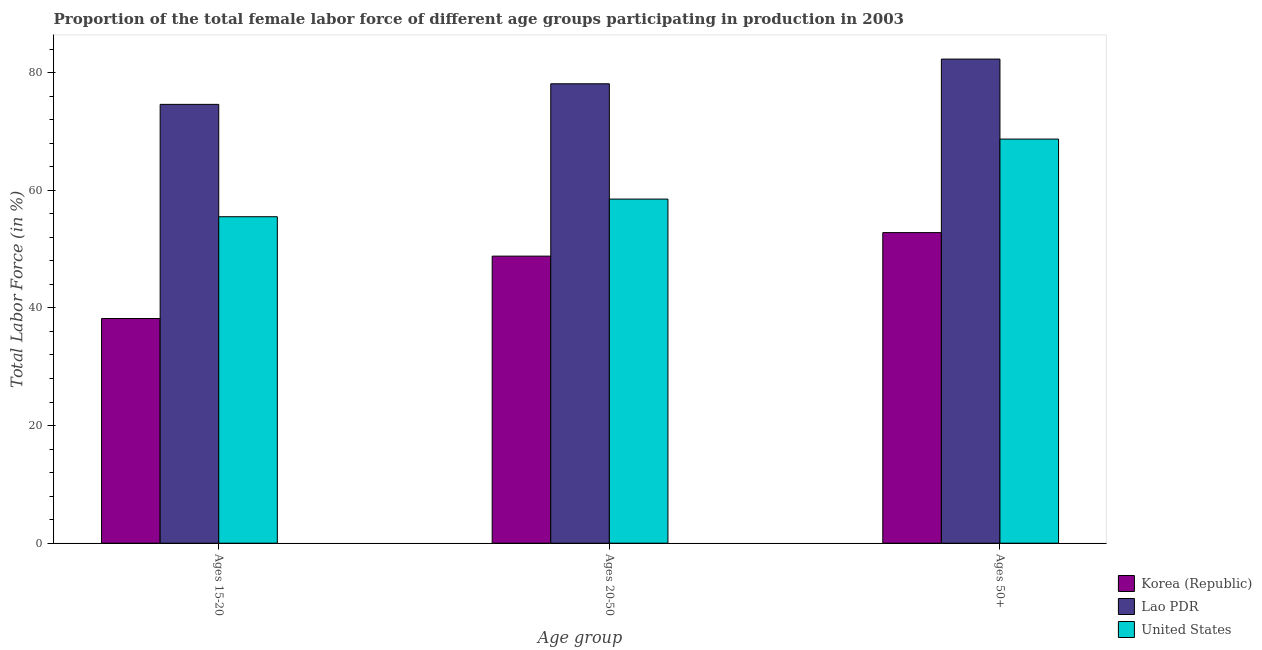How many different coloured bars are there?
Provide a short and direct response. 3. How many groups of bars are there?
Make the answer very short. 3. Are the number of bars on each tick of the X-axis equal?
Offer a terse response. Yes. How many bars are there on the 2nd tick from the right?
Provide a short and direct response. 3. What is the label of the 1st group of bars from the left?
Make the answer very short. Ages 15-20. What is the percentage of female labor force within the age group 20-50 in Korea (Republic)?
Your answer should be very brief. 48.8. Across all countries, what is the maximum percentage of female labor force within the age group 20-50?
Your response must be concise. 78.1. Across all countries, what is the minimum percentage of female labor force above age 50?
Your answer should be very brief. 52.8. In which country was the percentage of female labor force within the age group 15-20 maximum?
Ensure brevity in your answer.  Lao PDR. In which country was the percentage of female labor force above age 50 minimum?
Ensure brevity in your answer.  Korea (Republic). What is the total percentage of female labor force within the age group 15-20 in the graph?
Your answer should be very brief. 168.3. What is the difference between the percentage of female labor force within the age group 20-50 in Korea (Republic) and that in Lao PDR?
Your answer should be very brief. -29.3. What is the difference between the percentage of female labor force within the age group 20-50 in United States and the percentage of female labor force above age 50 in Korea (Republic)?
Make the answer very short. 5.7. What is the average percentage of female labor force above age 50 per country?
Offer a terse response. 67.93. What is the difference between the percentage of female labor force above age 50 and percentage of female labor force within the age group 15-20 in United States?
Offer a terse response. 13.2. What is the ratio of the percentage of female labor force within the age group 20-50 in Lao PDR to that in Korea (Republic)?
Offer a terse response. 1.6. Is the percentage of female labor force within the age group 15-20 in Korea (Republic) less than that in Lao PDR?
Give a very brief answer. Yes. What is the difference between the highest and the second highest percentage of female labor force within the age group 20-50?
Ensure brevity in your answer.  19.6. What is the difference between the highest and the lowest percentage of female labor force within the age group 15-20?
Keep it short and to the point. 36.4. In how many countries, is the percentage of female labor force within the age group 15-20 greater than the average percentage of female labor force within the age group 15-20 taken over all countries?
Provide a short and direct response. 1. What does the 3rd bar from the left in Ages 15-20 represents?
Give a very brief answer. United States. What does the 3rd bar from the right in Ages 20-50 represents?
Keep it short and to the point. Korea (Republic). Are all the bars in the graph horizontal?
Offer a very short reply. No. Does the graph contain any zero values?
Provide a short and direct response. No. What is the title of the graph?
Keep it short and to the point. Proportion of the total female labor force of different age groups participating in production in 2003. What is the label or title of the X-axis?
Offer a terse response. Age group. What is the label or title of the Y-axis?
Provide a succinct answer. Total Labor Force (in %). What is the Total Labor Force (in %) in Korea (Republic) in Ages 15-20?
Ensure brevity in your answer.  38.2. What is the Total Labor Force (in %) of Lao PDR in Ages 15-20?
Provide a succinct answer. 74.6. What is the Total Labor Force (in %) of United States in Ages 15-20?
Provide a short and direct response. 55.5. What is the Total Labor Force (in %) of Korea (Republic) in Ages 20-50?
Offer a terse response. 48.8. What is the Total Labor Force (in %) of Lao PDR in Ages 20-50?
Your answer should be very brief. 78.1. What is the Total Labor Force (in %) of United States in Ages 20-50?
Your answer should be very brief. 58.5. What is the Total Labor Force (in %) in Korea (Republic) in Ages 50+?
Offer a very short reply. 52.8. What is the Total Labor Force (in %) of Lao PDR in Ages 50+?
Offer a terse response. 82.3. What is the Total Labor Force (in %) in United States in Ages 50+?
Provide a succinct answer. 68.7. Across all Age group, what is the maximum Total Labor Force (in %) in Korea (Republic)?
Make the answer very short. 52.8. Across all Age group, what is the maximum Total Labor Force (in %) of Lao PDR?
Keep it short and to the point. 82.3. Across all Age group, what is the maximum Total Labor Force (in %) of United States?
Your answer should be very brief. 68.7. Across all Age group, what is the minimum Total Labor Force (in %) in Korea (Republic)?
Your answer should be very brief. 38.2. Across all Age group, what is the minimum Total Labor Force (in %) in Lao PDR?
Offer a terse response. 74.6. Across all Age group, what is the minimum Total Labor Force (in %) of United States?
Give a very brief answer. 55.5. What is the total Total Labor Force (in %) of Korea (Republic) in the graph?
Your response must be concise. 139.8. What is the total Total Labor Force (in %) in Lao PDR in the graph?
Provide a short and direct response. 235. What is the total Total Labor Force (in %) of United States in the graph?
Offer a very short reply. 182.7. What is the difference between the Total Labor Force (in %) in Korea (Republic) in Ages 15-20 and that in Ages 50+?
Provide a succinct answer. -14.6. What is the difference between the Total Labor Force (in %) in Lao PDR in Ages 15-20 and that in Ages 50+?
Your response must be concise. -7.7. What is the difference between the Total Labor Force (in %) in Lao PDR in Ages 20-50 and that in Ages 50+?
Offer a very short reply. -4.2. What is the difference between the Total Labor Force (in %) in Korea (Republic) in Ages 15-20 and the Total Labor Force (in %) in Lao PDR in Ages 20-50?
Provide a succinct answer. -39.9. What is the difference between the Total Labor Force (in %) in Korea (Republic) in Ages 15-20 and the Total Labor Force (in %) in United States in Ages 20-50?
Give a very brief answer. -20.3. What is the difference between the Total Labor Force (in %) in Korea (Republic) in Ages 15-20 and the Total Labor Force (in %) in Lao PDR in Ages 50+?
Offer a very short reply. -44.1. What is the difference between the Total Labor Force (in %) of Korea (Republic) in Ages 15-20 and the Total Labor Force (in %) of United States in Ages 50+?
Provide a succinct answer. -30.5. What is the difference between the Total Labor Force (in %) in Lao PDR in Ages 15-20 and the Total Labor Force (in %) in United States in Ages 50+?
Offer a very short reply. 5.9. What is the difference between the Total Labor Force (in %) of Korea (Republic) in Ages 20-50 and the Total Labor Force (in %) of Lao PDR in Ages 50+?
Offer a terse response. -33.5. What is the difference between the Total Labor Force (in %) of Korea (Republic) in Ages 20-50 and the Total Labor Force (in %) of United States in Ages 50+?
Make the answer very short. -19.9. What is the average Total Labor Force (in %) in Korea (Republic) per Age group?
Ensure brevity in your answer.  46.6. What is the average Total Labor Force (in %) in Lao PDR per Age group?
Your response must be concise. 78.33. What is the average Total Labor Force (in %) in United States per Age group?
Provide a short and direct response. 60.9. What is the difference between the Total Labor Force (in %) in Korea (Republic) and Total Labor Force (in %) in Lao PDR in Ages 15-20?
Provide a short and direct response. -36.4. What is the difference between the Total Labor Force (in %) in Korea (Republic) and Total Labor Force (in %) in United States in Ages 15-20?
Your answer should be compact. -17.3. What is the difference between the Total Labor Force (in %) of Korea (Republic) and Total Labor Force (in %) of Lao PDR in Ages 20-50?
Provide a short and direct response. -29.3. What is the difference between the Total Labor Force (in %) of Lao PDR and Total Labor Force (in %) of United States in Ages 20-50?
Make the answer very short. 19.6. What is the difference between the Total Labor Force (in %) of Korea (Republic) and Total Labor Force (in %) of Lao PDR in Ages 50+?
Your answer should be very brief. -29.5. What is the difference between the Total Labor Force (in %) in Korea (Republic) and Total Labor Force (in %) in United States in Ages 50+?
Your response must be concise. -15.9. What is the difference between the Total Labor Force (in %) in Lao PDR and Total Labor Force (in %) in United States in Ages 50+?
Provide a short and direct response. 13.6. What is the ratio of the Total Labor Force (in %) of Korea (Republic) in Ages 15-20 to that in Ages 20-50?
Provide a succinct answer. 0.78. What is the ratio of the Total Labor Force (in %) of Lao PDR in Ages 15-20 to that in Ages 20-50?
Your answer should be compact. 0.96. What is the ratio of the Total Labor Force (in %) in United States in Ages 15-20 to that in Ages 20-50?
Make the answer very short. 0.95. What is the ratio of the Total Labor Force (in %) in Korea (Republic) in Ages 15-20 to that in Ages 50+?
Keep it short and to the point. 0.72. What is the ratio of the Total Labor Force (in %) in Lao PDR in Ages 15-20 to that in Ages 50+?
Give a very brief answer. 0.91. What is the ratio of the Total Labor Force (in %) in United States in Ages 15-20 to that in Ages 50+?
Your answer should be compact. 0.81. What is the ratio of the Total Labor Force (in %) of Korea (Republic) in Ages 20-50 to that in Ages 50+?
Provide a succinct answer. 0.92. What is the ratio of the Total Labor Force (in %) of Lao PDR in Ages 20-50 to that in Ages 50+?
Keep it short and to the point. 0.95. What is the ratio of the Total Labor Force (in %) of United States in Ages 20-50 to that in Ages 50+?
Your answer should be very brief. 0.85. What is the difference between the highest and the second highest Total Labor Force (in %) in Korea (Republic)?
Offer a very short reply. 4. What is the difference between the highest and the second highest Total Labor Force (in %) in Lao PDR?
Give a very brief answer. 4.2. What is the difference between the highest and the second highest Total Labor Force (in %) of United States?
Make the answer very short. 10.2. What is the difference between the highest and the lowest Total Labor Force (in %) in Korea (Republic)?
Offer a terse response. 14.6. What is the difference between the highest and the lowest Total Labor Force (in %) of United States?
Provide a short and direct response. 13.2. 